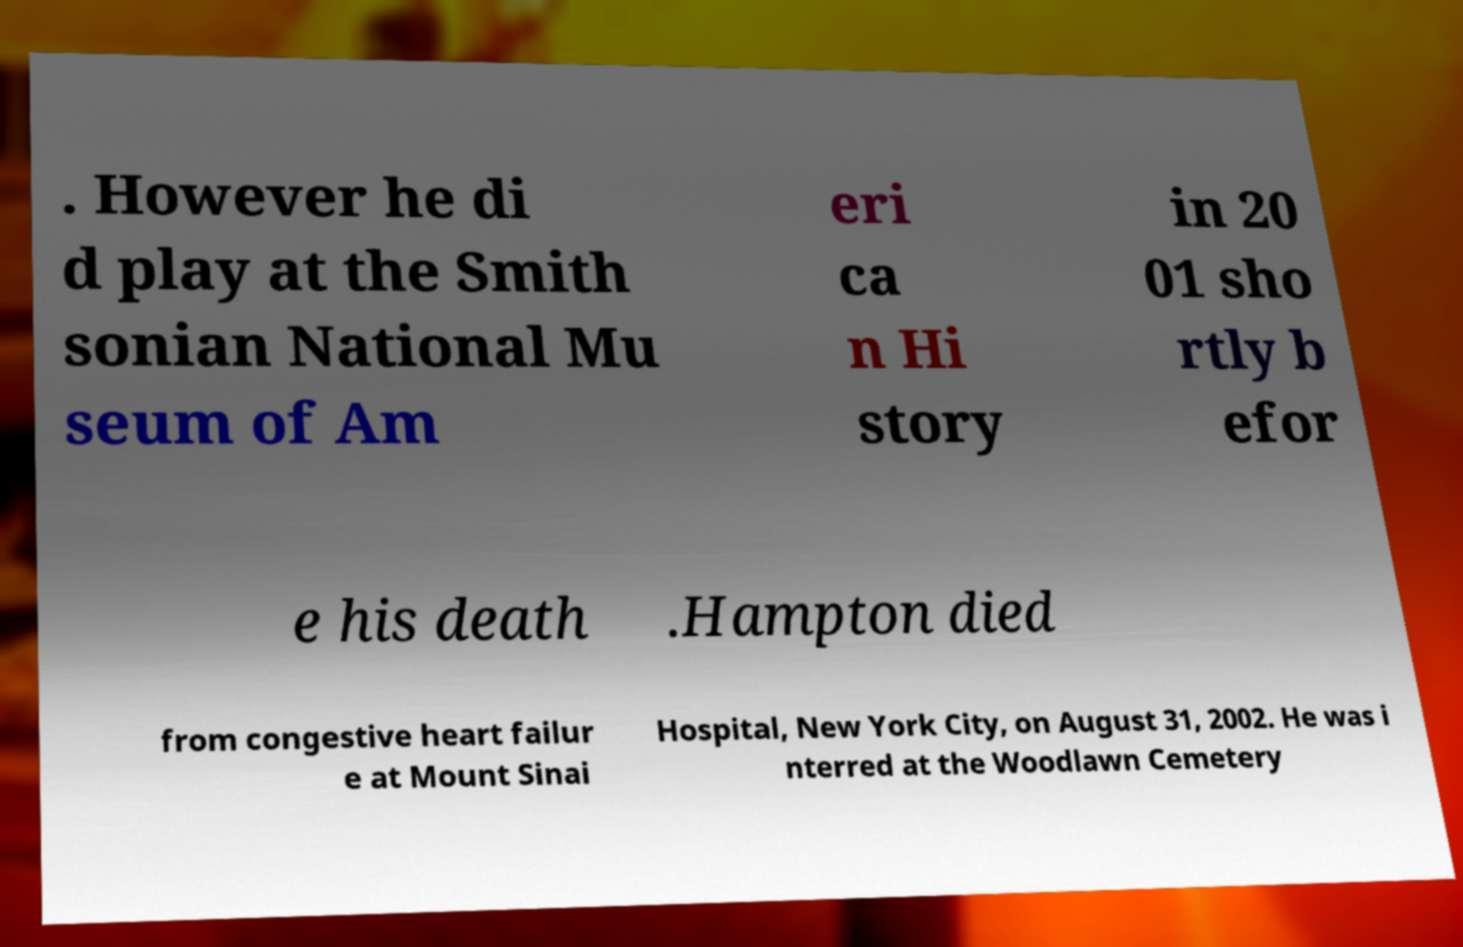There's text embedded in this image that I need extracted. Can you transcribe it verbatim? . However he di d play at the Smith sonian National Mu seum of Am eri ca n Hi story in 20 01 sho rtly b efor e his death .Hampton died from congestive heart failur e at Mount Sinai Hospital, New York City, on August 31, 2002. He was i nterred at the Woodlawn Cemetery 